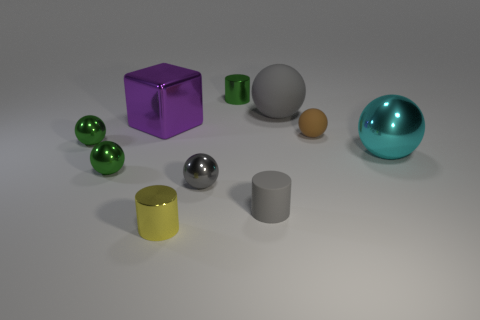Subtract 2 spheres. How many spheres are left? 4 Subtract all gray balls. How many balls are left? 4 Subtract all big gray spheres. How many spheres are left? 5 Subtract all blue spheres. Subtract all red blocks. How many spheres are left? 6 Subtract all cubes. How many objects are left? 9 Subtract 0 red spheres. How many objects are left? 10 Subtract all large yellow matte balls. Subtract all cyan shiny objects. How many objects are left? 9 Add 8 large gray balls. How many large gray balls are left? 9 Add 6 cubes. How many cubes exist? 7 